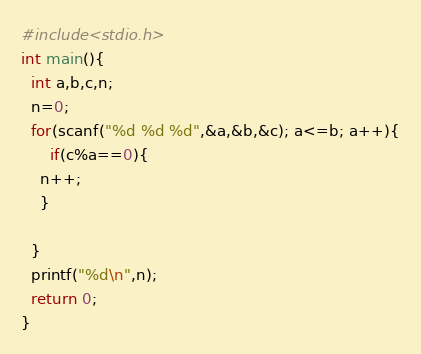Convert code to text. <code><loc_0><loc_0><loc_500><loc_500><_C_>#include<stdio.h>
int main(){
  int a,b,c,n;
  n=0;
  for(scanf("%d %d %d",&a,&b,&c); a<=b; a++){
      if(c%a==0){
	n++;
    }
   
  }
  printf("%d\n",n);
  return 0;
}</code> 